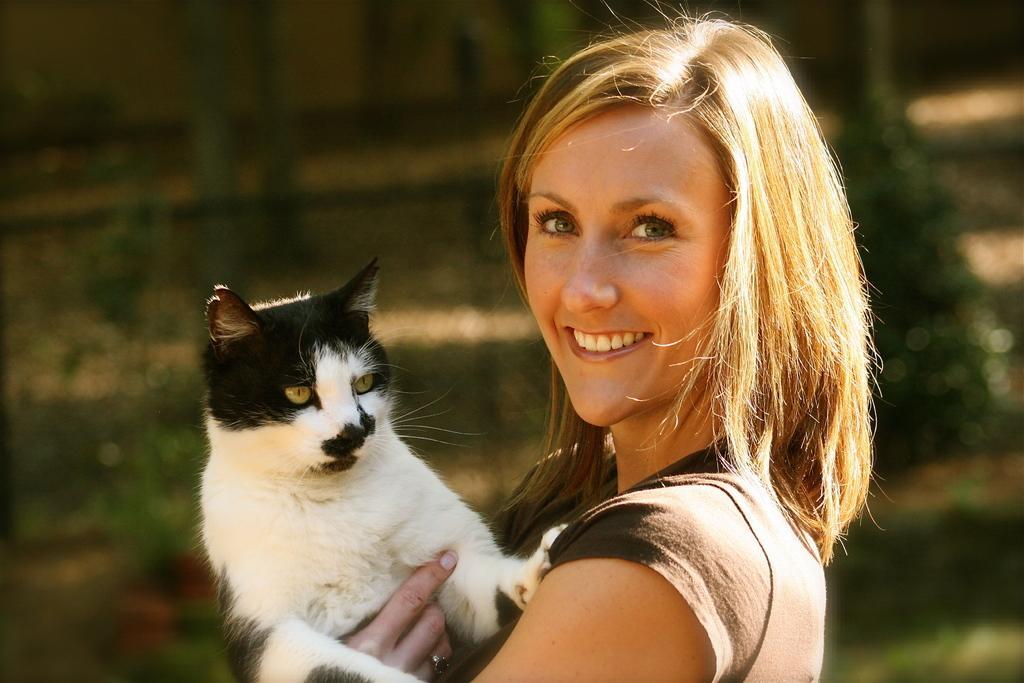Can you describe this image briefly? In this image there is a woman holding a cat in her hand. She is smiling. The cat is black and white in color. The background is blurred. 